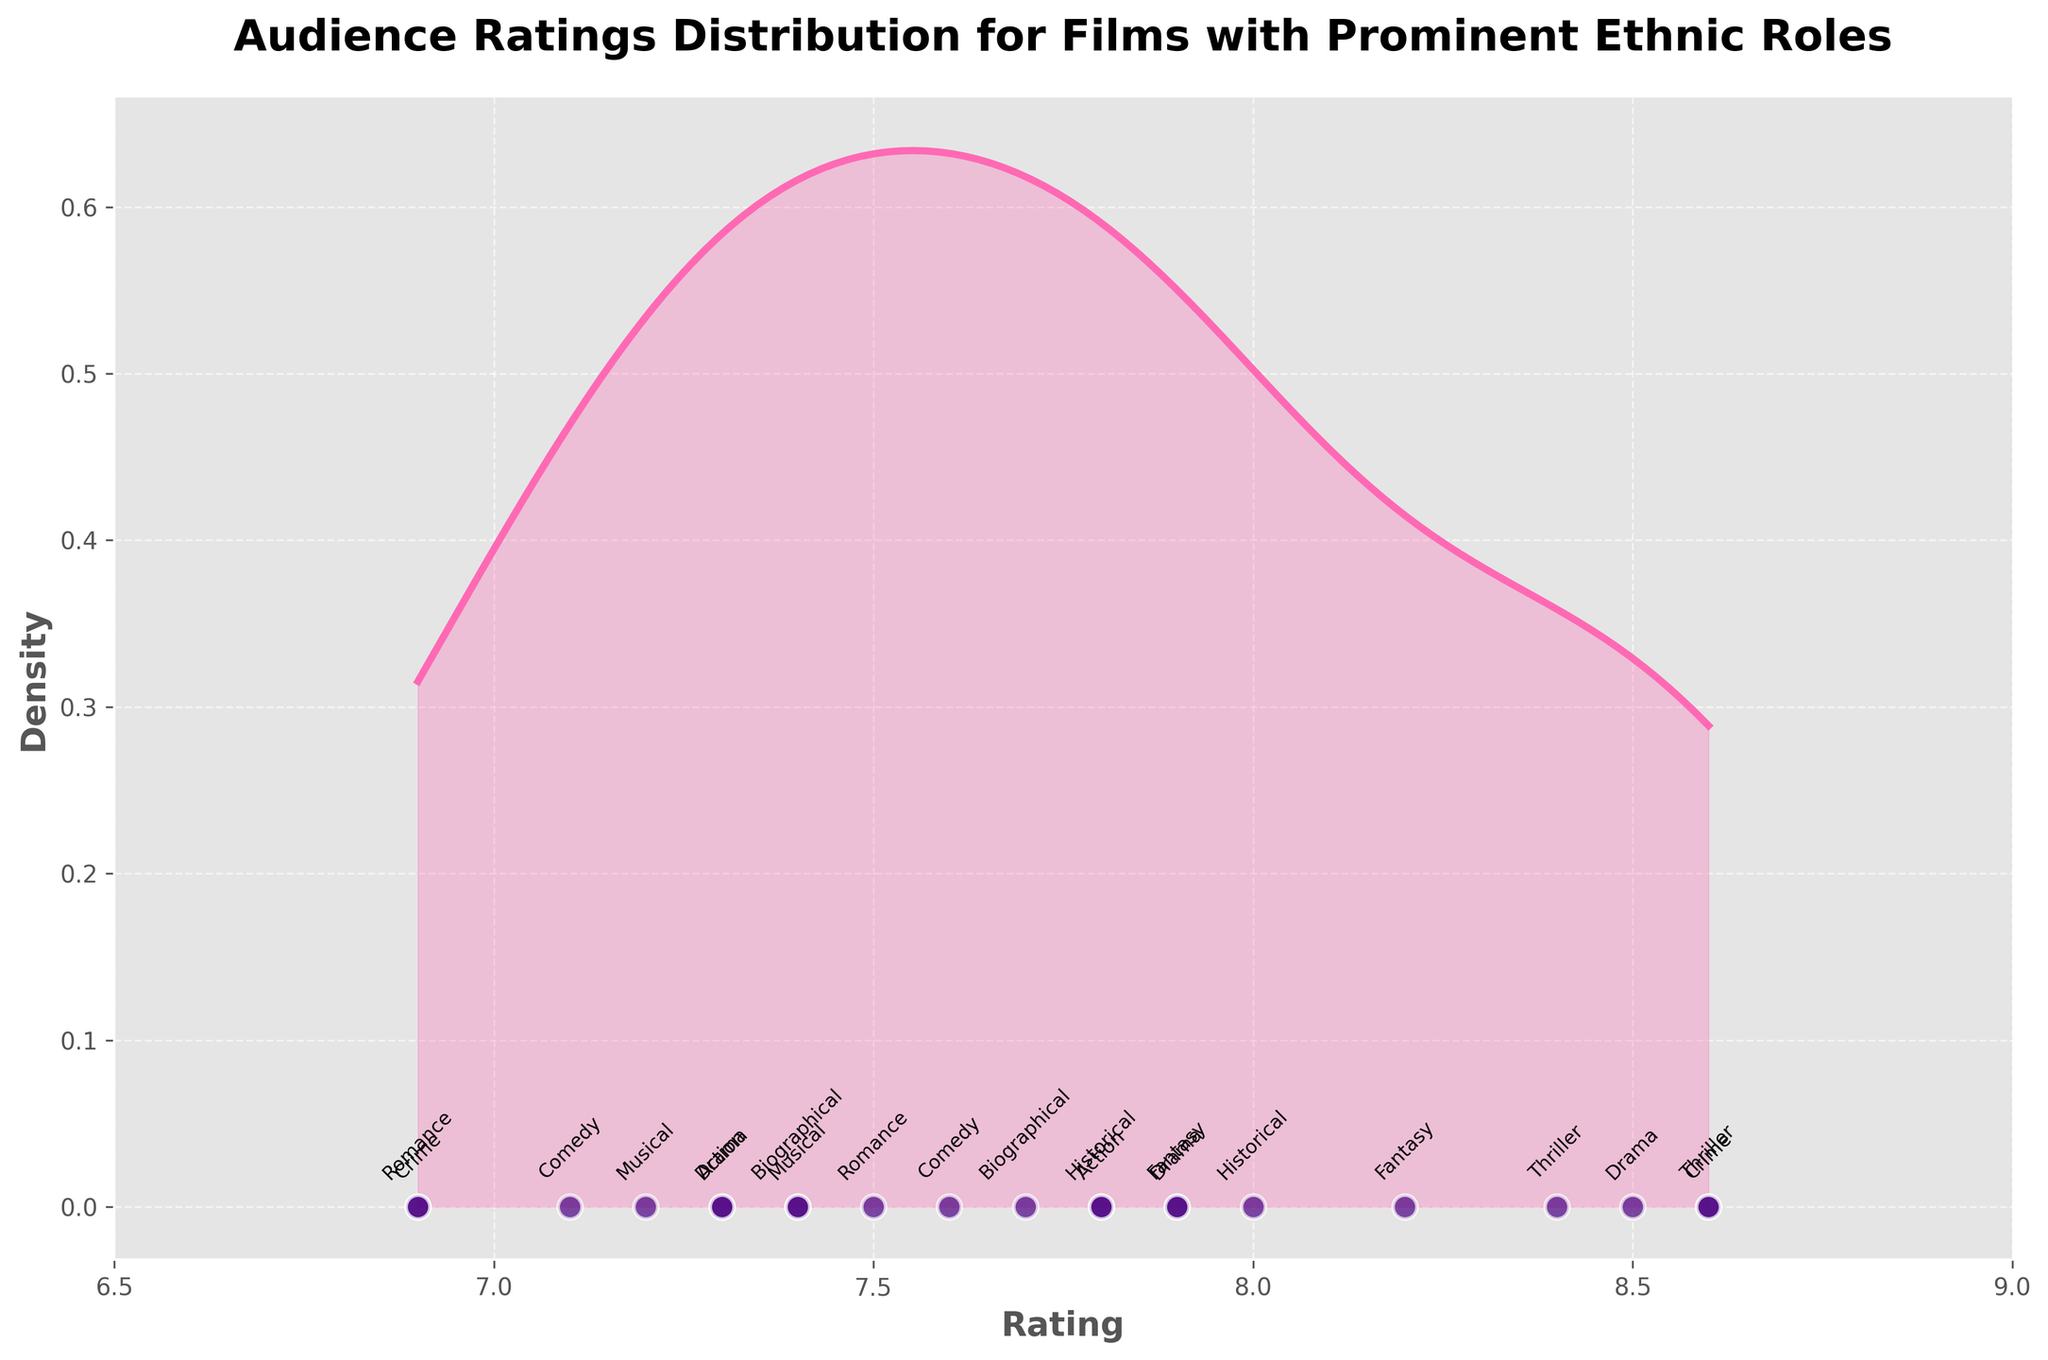what is the title of the plot? The title is clearly indicated at the top of the plot and summarizes the main focus of the plot as "Audience Ratings Distribution for Films with Prominent Ethnic Roles".
Answer: Audience Ratings Distribution for Films with Prominent Ethnic Roles What is the range of ratings displayed on the x-axis? The x-axis scale is visible along the bottom of the plot, indicating that the ratings range from 6.5 to 9.
Answer: 6.5 to 9 Which genre has the highest audience rating and what is that rating? By examining the scatter points and their associated labels, we see that the thriller genre ("Parasite") has the highest audience rating of 8.6.
Answer: Thriller, 8.6 What is the lowest audience rating and which film has this rating? Observe the scatter plot points along the x-axis; "Widows" from the Crime genre has the lowest rating at 6.9.
Answer: Widows, 6.9 How many genres have an audience rating of 8.0 or higher? Count the number of scatter points on or above the 8.0 mark on the x-axis and label them. There are films from genres Drama, Historical, Thriller, Fantasy, and Crime that meet this criterion.
Answer: 5 genres Which film in the Action genre has the highest rating? Look at the scatter points and their labels; "Crouching Tiger, Hidden Dragon" has the highest rating among Action films at 7.8.
Answer: Crouching Tiger, Hidden Dragon How do the density peaks suggest the general audience rating trend for these films? The density curve peaks indicate where most of the audience ratings are clustered. The main peak is around 7.8, suggesting that the majority of the ratings are around this value.
Answer: Around 7.8 Compare the highest rating in the Drama genre with the highest rating in the Comedy genre. Which one is higher and by how much? Find the highest rating in Drama ("Slumdog Millionaire" with 8.5) and Comedy ("The Big Sick" with 7.6). The Drama rating is higher by 0.9.
Answer: Drama is higher by 0.9 Which genre labels are found closest to the lowest density areas under the curve and what rating do they correspond to? Examine the plot where the density curve dips lowest and check the scatter points in those regions. The genre "Crime" with film "Widows" (rating 6.9) and "Romance" with "Mississippi Masala" (rating 6.9) are in these low-density extremes.
Answer: Crime (Widows), Romance (Mississippi Masala), 6.9 What can you conclude about the spread of audience ratings among different genres based on the density plot? The density plot shows a concentration of ratings around 7.5 to 8 with fewer ratings outside this range, indicating most films are rated relatively consistently within this band.
Answer: Most ratings are between 7.5 and 8 